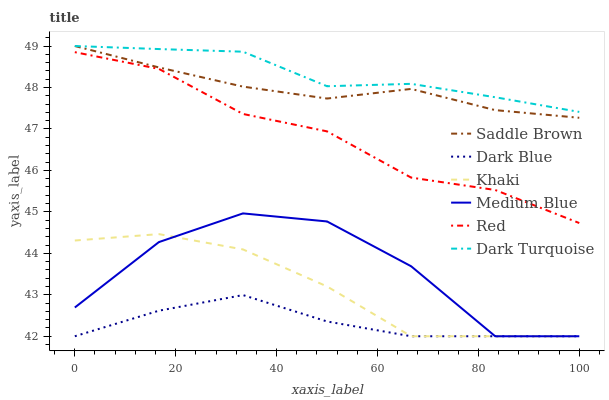Does Dark Blue have the minimum area under the curve?
Answer yes or no. Yes. Does Dark Turquoise have the maximum area under the curve?
Answer yes or no. Yes. Does Medium Blue have the minimum area under the curve?
Answer yes or no. No. Does Medium Blue have the maximum area under the curve?
Answer yes or no. No. Is Saddle Brown the smoothest?
Answer yes or no. Yes. Is Medium Blue the roughest?
Answer yes or no. Yes. Is Dark Turquoise the smoothest?
Answer yes or no. No. Is Dark Turquoise the roughest?
Answer yes or no. No. Does Dark Turquoise have the lowest value?
Answer yes or no. No. Does Saddle Brown have the highest value?
Answer yes or no. Yes. Does Medium Blue have the highest value?
Answer yes or no. No. Is Medium Blue less than Saddle Brown?
Answer yes or no. Yes. Is Dark Turquoise greater than Red?
Answer yes or no. Yes. Does Medium Blue intersect Saddle Brown?
Answer yes or no. No. 